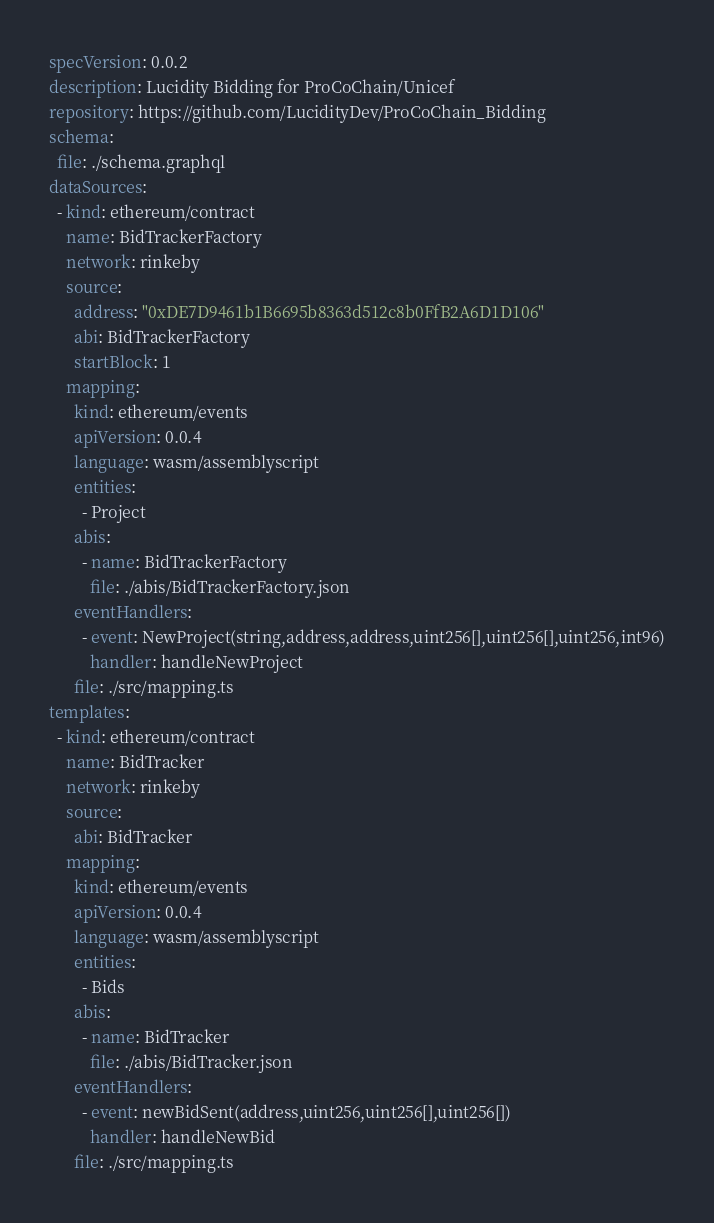<code> <loc_0><loc_0><loc_500><loc_500><_YAML_>specVersion: 0.0.2
description: Lucidity Bidding for ProCoChain/Unicef
repository: https://github.com/LucidityDev/ProCoChain_Bidding
schema:
  file: ./schema.graphql
dataSources:
  - kind: ethereum/contract
    name: BidTrackerFactory
    network: rinkeby
    source:
      address: "0xDE7D9461b1B6695b8363d512c8b0FfB2A6D1D106"
      abi: BidTrackerFactory
      startBlock: 1
    mapping:
      kind: ethereum/events
      apiVersion: 0.0.4
      language: wasm/assemblyscript
      entities:
        - Project
      abis:
        - name: BidTrackerFactory
          file: ./abis/BidTrackerFactory.json
      eventHandlers:
        - event: NewProject(string,address,address,uint256[],uint256[],uint256,int96)
          handler: handleNewProject
      file: ./src/mapping.ts
templates:
  - kind: ethereum/contract
    name: BidTracker
    network: rinkeby
    source:
      abi: BidTracker
    mapping:
      kind: ethereum/events
      apiVersion: 0.0.4
      language: wasm/assemblyscript
      entities:
        - Bids
      abis:
        - name: BidTracker
          file: ./abis/BidTracker.json
      eventHandlers:
        - event: newBidSent(address,uint256,uint256[],uint256[])
          handler: handleNewBid
      file: ./src/mapping.ts
</code> 